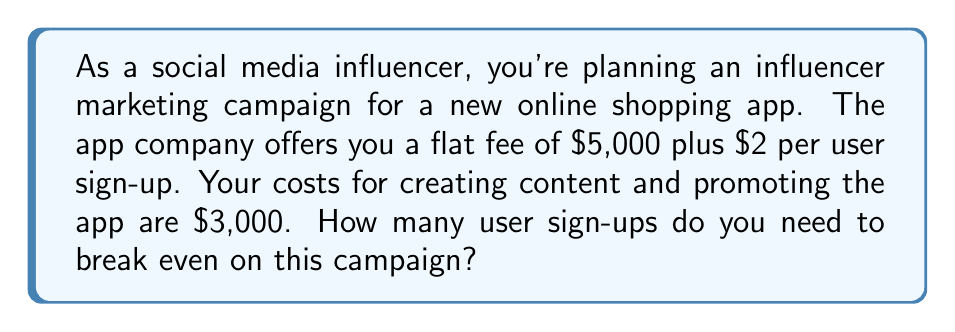Help me with this question. Let's approach this step-by-step:

1) First, let's define our variables:
   $x$ = number of user sign-ups
   $R$ = Revenue
   $C$ = Costs

2) We can express the revenue as:
   $R = 5000 + 2x$

3) The costs are:
   $C = 3000$

4) At the break-even point, revenue equals costs:
   $R = C$

5) We can now set up our equation:
   $5000 + 2x = 3000$

6) Subtract 5000 from both sides:
   $2x = -2000$

7) Divide both sides by 2:
   $x = -1000$

8) However, since we can't have negative sign-ups, we need to interpret this result. The negative number indicates that we've already broken even before getting any sign-ups. This is because the flat fee ($5000) is greater than our costs ($3000).

9) To find how many sign-ups we need to break even, we can calculate:
   $\frac{3000 - 5000}{2} = -1000$

This confirms our earlier result.
Answer: 0 sign-ups (break-even occurs immediately due to flat fee) 